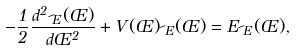<formula> <loc_0><loc_0><loc_500><loc_500>- \frac { 1 } { 2 } \frac { d ^ { 2 } \psi _ { E } ( \phi ) } { d \phi ^ { 2 } } + V ( \phi ) \psi _ { E } ( \phi ) = E \psi _ { E } ( \phi ) ,</formula> 